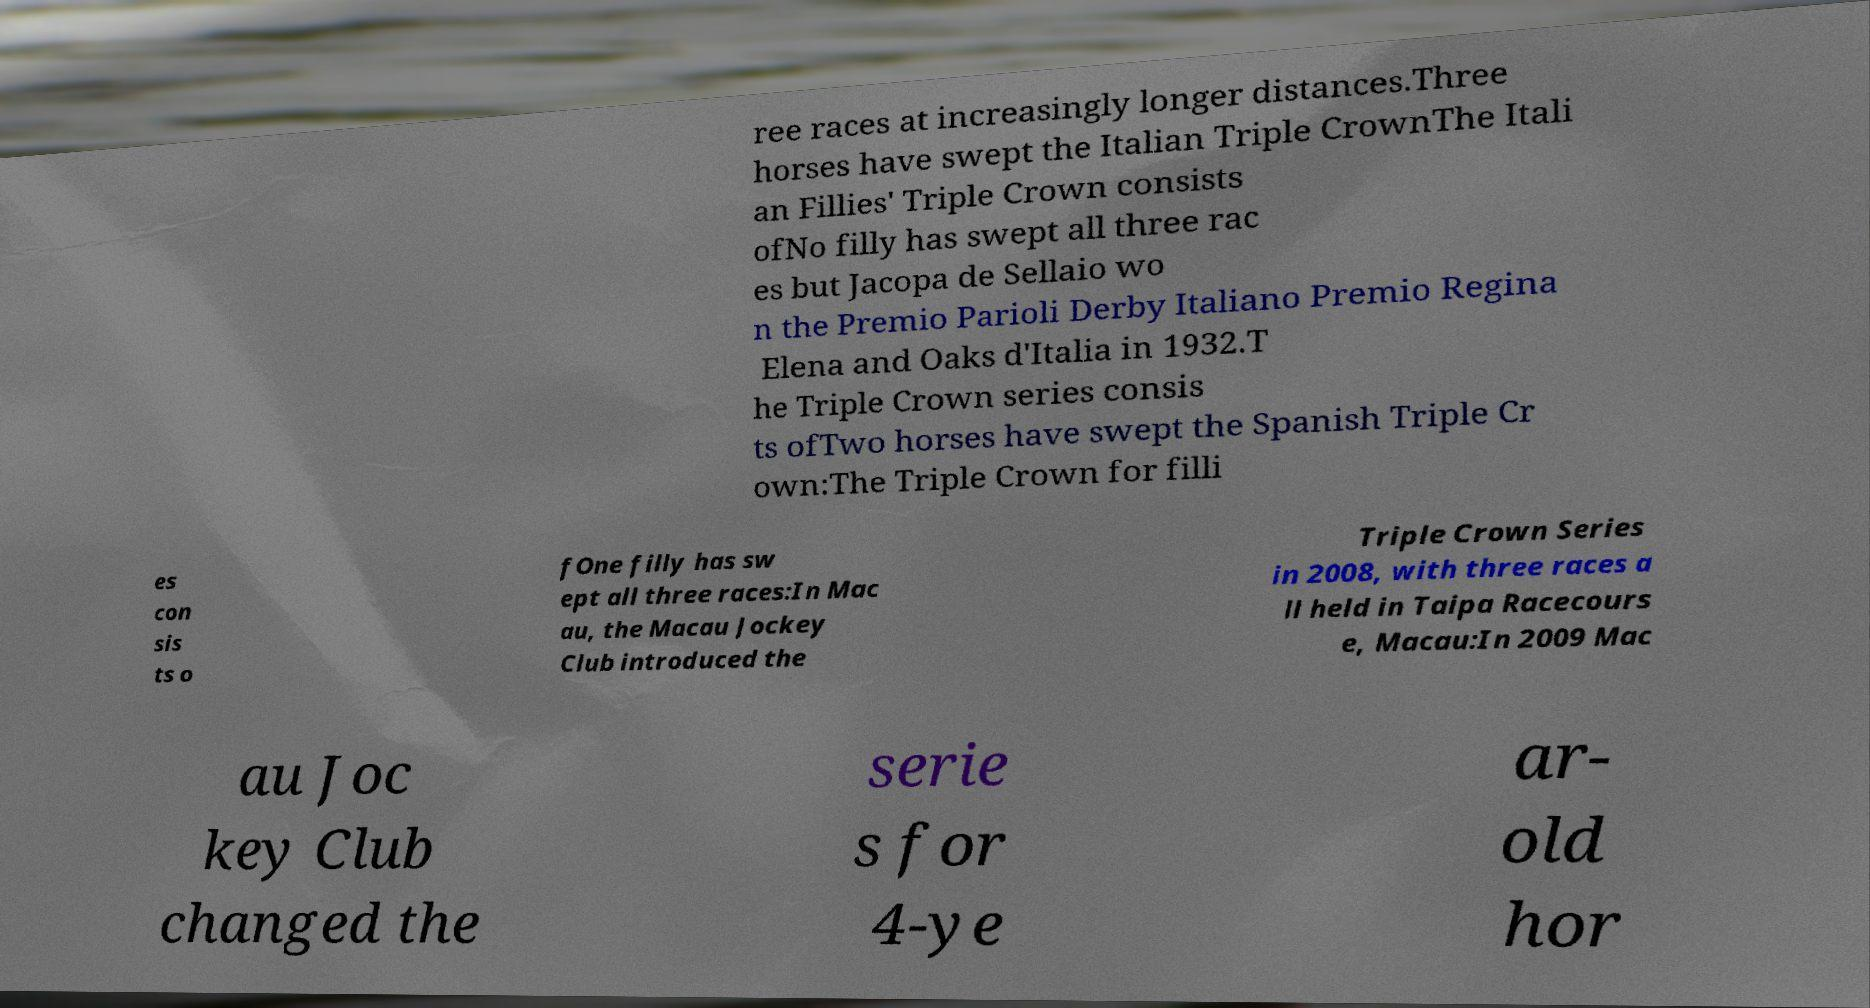Can you read and provide the text displayed in the image?This photo seems to have some interesting text. Can you extract and type it out for me? ree races at increasingly longer distances.Three horses have swept the Italian Triple CrownThe Itali an Fillies' Triple Crown consists ofNo filly has swept all three rac es but Jacopa de Sellaio wo n the Premio Parioli Derby Italiano Premio Regina Elena and Oaks d'Italia in 1932.T he Triple Crown series consis ts ofTwo horses have swept the Spanish Triple Cr own:The Triple Crown for filli es con sis ts o fOne filly has sw ept all three races:In Mac au, the Macau Jockey Club introduced the Triple Crown Series in 2008, with three races a ll held in Taipa Racecours e, Macau:In 2009 Mac au Joc key Club changed the serie s for 4-ye ar- old hor 